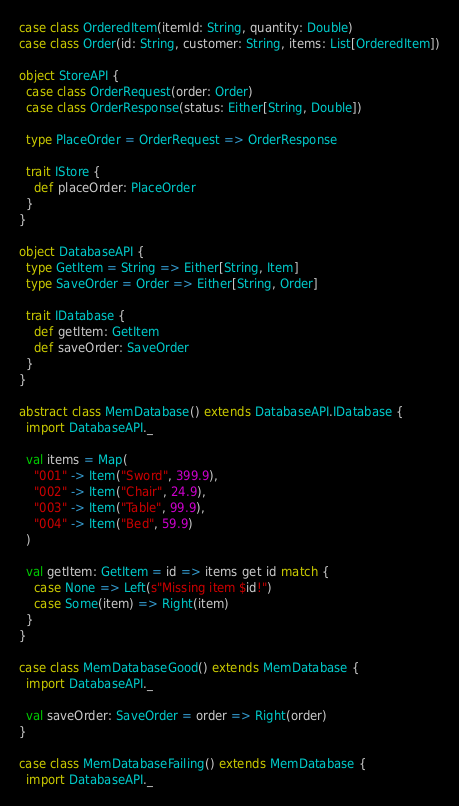<code> <loc_0><loc_0><loc_500><loc_500><_Scala_>case class OrderedItem(itemId: String, quantity: Double)
case class Order(id: String, customer: String, items: List[OrderedItem])

object StoreAPI {
  case class OrderRequest(order: Order)
  case class OrderResponse(status: Either[String, Double])

  type PlaceOrder = OrderRequest => OrderResponse

  trait IStore {
    def placeOrder: PlaceOrder
  }
}

object DatabaseAPI {
  type GetItem = String => Either[String, Item]
  type SaveOrder = Order => Either[String, Order]

  trait IDatabase {
    def getItem: GetItem
    def saveOrder: SaveOrder
  }
}

abstract class MemDatabase() extends DatabaseAPI.IDatabase {
  import DatabaseAPI._

  val items = Map(
    "001" -> Item("Sword", 399.9),
    "002" -> Item("Chair", 24.9),
    "003" -> Item("Table", 99.9),
    "004" -> Item("Bed", 59.9)
  )

  val getItem: GetItem = id => items get id match {
    case None => Left(s"Missing item $id!")
    case Some(item) => Right(item)
  }
}

case class MemDatabaseGood() extends MemDatabase {
  import DatabaseAPI._

  val saveOrder: SaveOrder = order => Right(order)
}

case class MemDatabaseFailing() extends MemDatabase {
  import DatabaseAPI._
</code> 